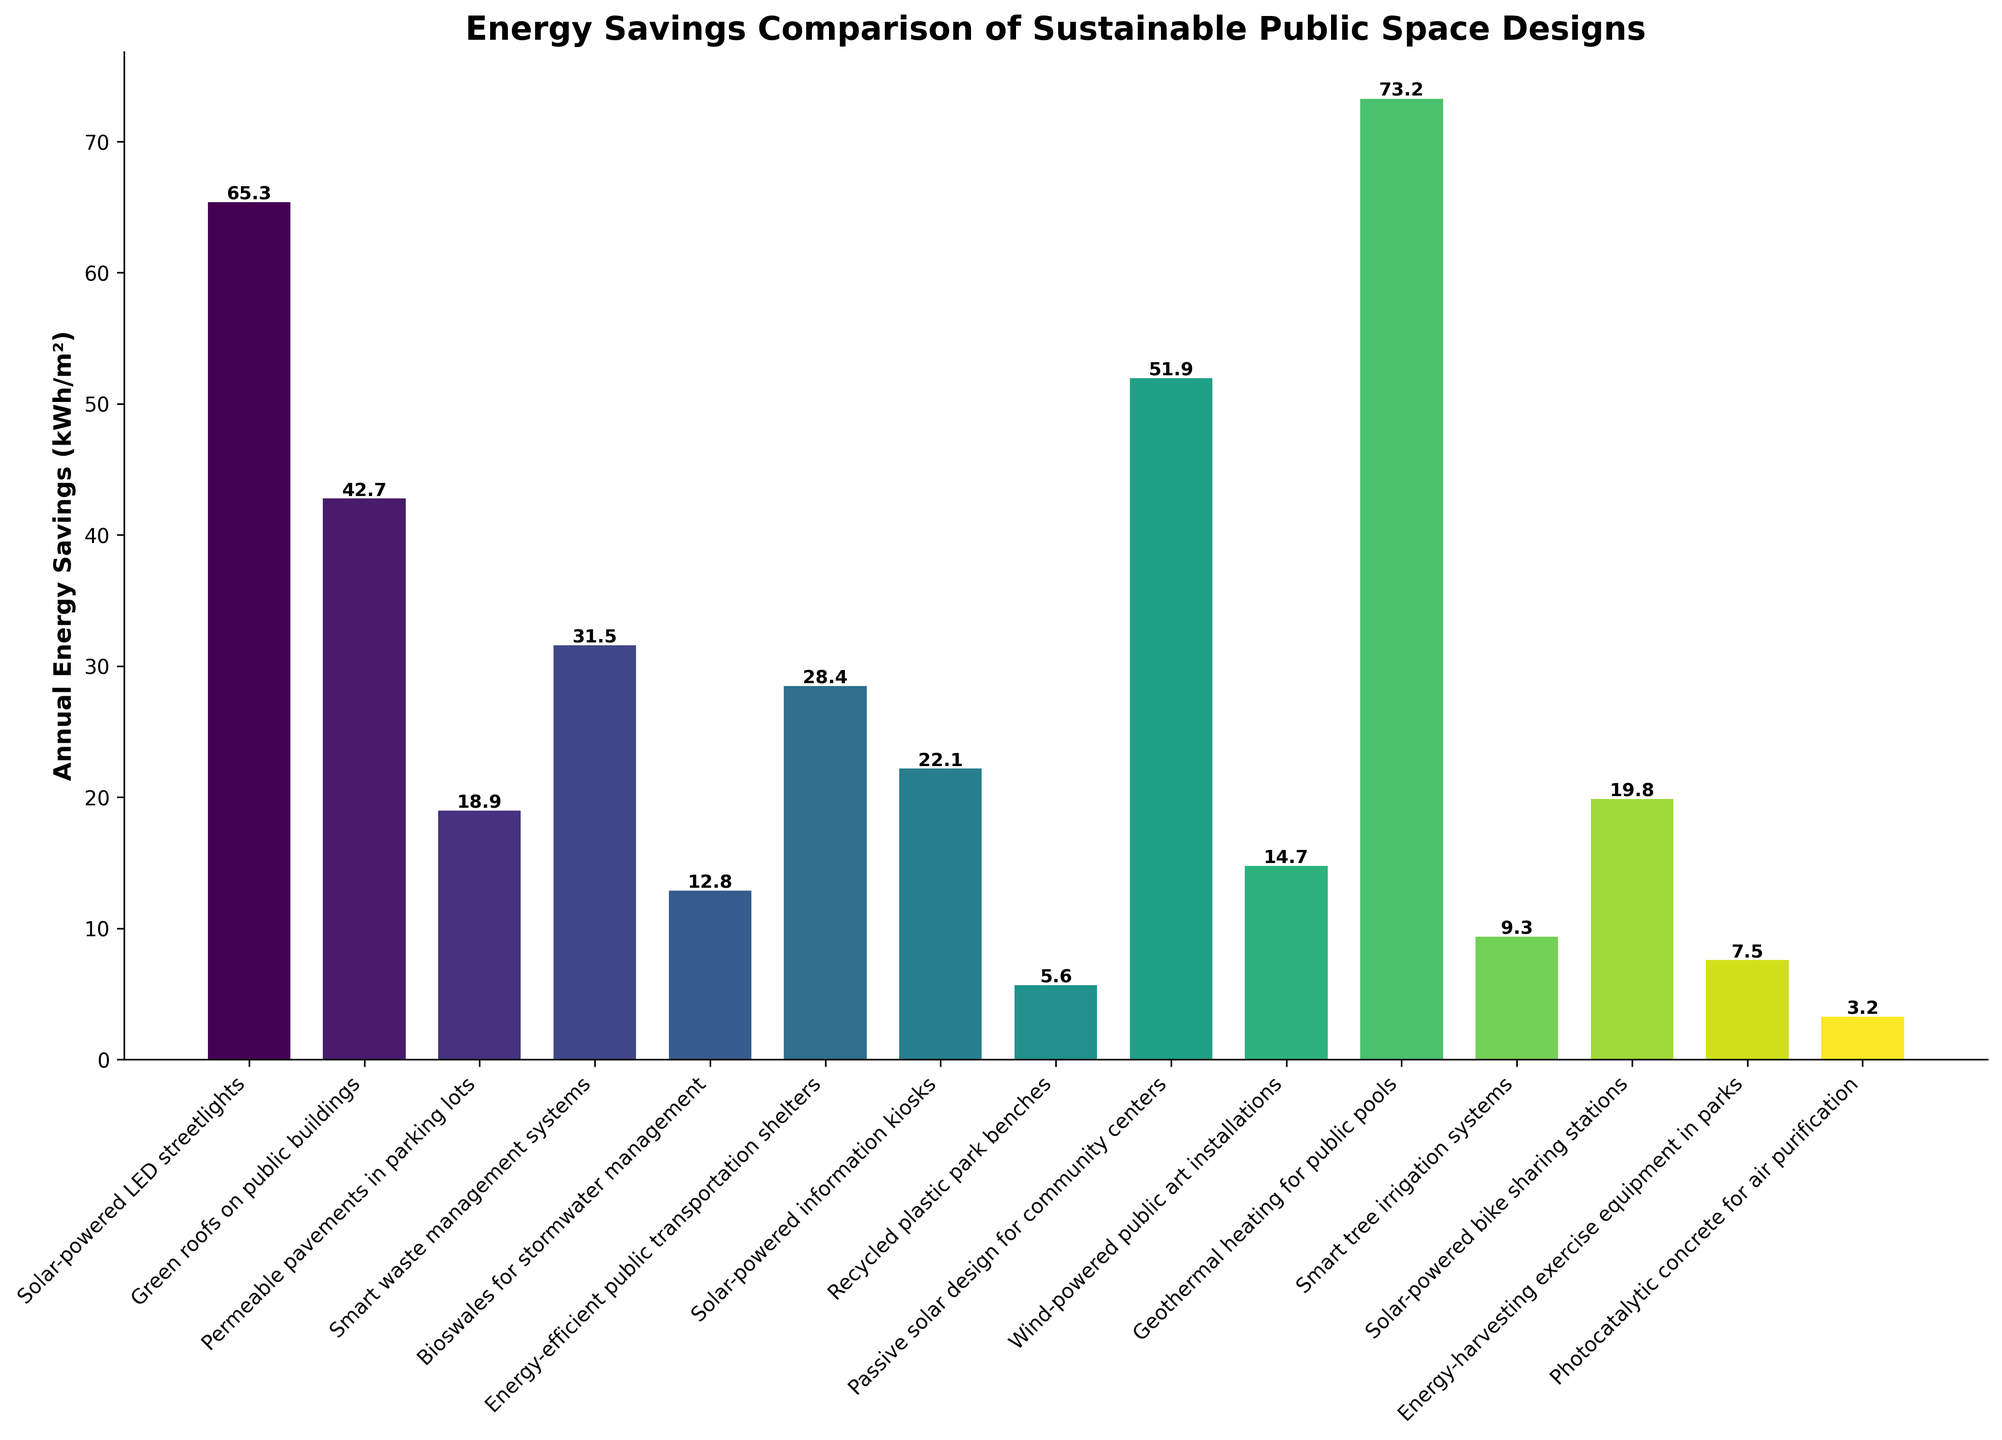What's the design with the highest annual energy savings? To determine the highest annual energy savings, we need to look for the tallest bar in the chart. The design with the tallest bar represents "Geothermal heating for public pools" at 73.2 kWh/m².
Answer: Geothermal heating for public pools Which design has lower annual energy savings: smart waste management systems or solar-powered bike sharing stations? First, locate the bars for "smart waste management systems" and "solar-powered bike sharing stations." Compare their heights. "Smart waste management systems" has 31.5 kWh/m², while "solar-powered bike sharing stations" has 19.8 kWh/m².
Answer: Solar-powered bike sharing stations What is the total annual energy savings of green roofs and passive solar design? We need to sum the annual energy savings of "green roofs on public buildings" (42.7 kWh/m²) and "passive solar design for community centers" (51.9 kWh/m²). 42.7 + 51.9 = 94.6 kWh/m².
Answer: 94.6 kWh/m² Which two designs have the smallest difference in annual energy savings? Identify the bars with the closest heights. Comparing values, "Recycled plastic park benches" at 5.6 kWh/m² and "Photocatalytic concrete for air purification" at 3.2 kWh/m² have the smallest difference: 5.6 - 3.2 = 2.4 kWh/m².
Answer: Recycled plastic park benches and Photocatalytic concrete for air purification How does the energy savings of green roofs compare to energy-efficient public transportation shelters? Compare the heights of the bars. "Green roofs on public buildings" have 42.7 kWh/m², while "Energy-efficient public transportation shelters" have 28.4 kWh/m². Green roofs save more energy.
Answer: Green roofs on public buildings What's the average annual energy savings of the designs with more than 40 kWh/m² savings? Identify the designs with more than 40 kWh/m² savings: "Solar-powered LED streetlights" (65.3), "Green roofs on public buildings" (42.7), "Passive solar design for community centers" (51.9), and "Geothermal heating for public pools" (73.2). Calculate the average: (65.3 + 42.7 + 51.9 + 73.2) / 4 = 58.275 kWh/m².
Answer: 58.275 kWh/m² What is the difference in annual energy savings between the highest and lowest designs? Find the highest (73.2 kWh/m² for "Geothermal heating for public pools") and lowest (3.2 kWh/m² for "Photocatalytic concrete for air purification") values. Calculate the difference: 73.2 - 3.2 = 70 kWh/m².
Answer: 70 kWh/m² Which design has a darker bar: energy-harvesting exercise equipment or smart tree irrigation systems? Darker colors in the chart typically represent higher values. Compare heights: "Smart tree irrigation systems" at 9.3 kWh/m² is darker than "Energy-harvesting exercise equipment" at 7.5 kWh/m².
Answer: Smart tree irrigation systems 